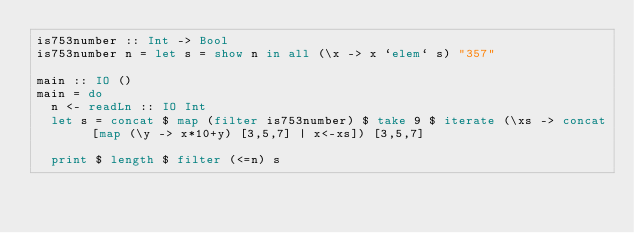<code> <loc_0><loc_0><loc_500><loc_500><_Haskell_>is753number :: Int -> Bool
is753number n = let s = show n in all (\x -> x `elem` s) "357" 

main :: IO ()
main = do
  n <- readLn :: IO Int
  let s = concat $ map (filter is753number) $ take 9 $ iterate (\xs -> concat [map (\y -> x*10+y) [3,5,7] | x<-xs]) [3,5,7]
  
  print $ length $ filter (<=n) s
</code> 